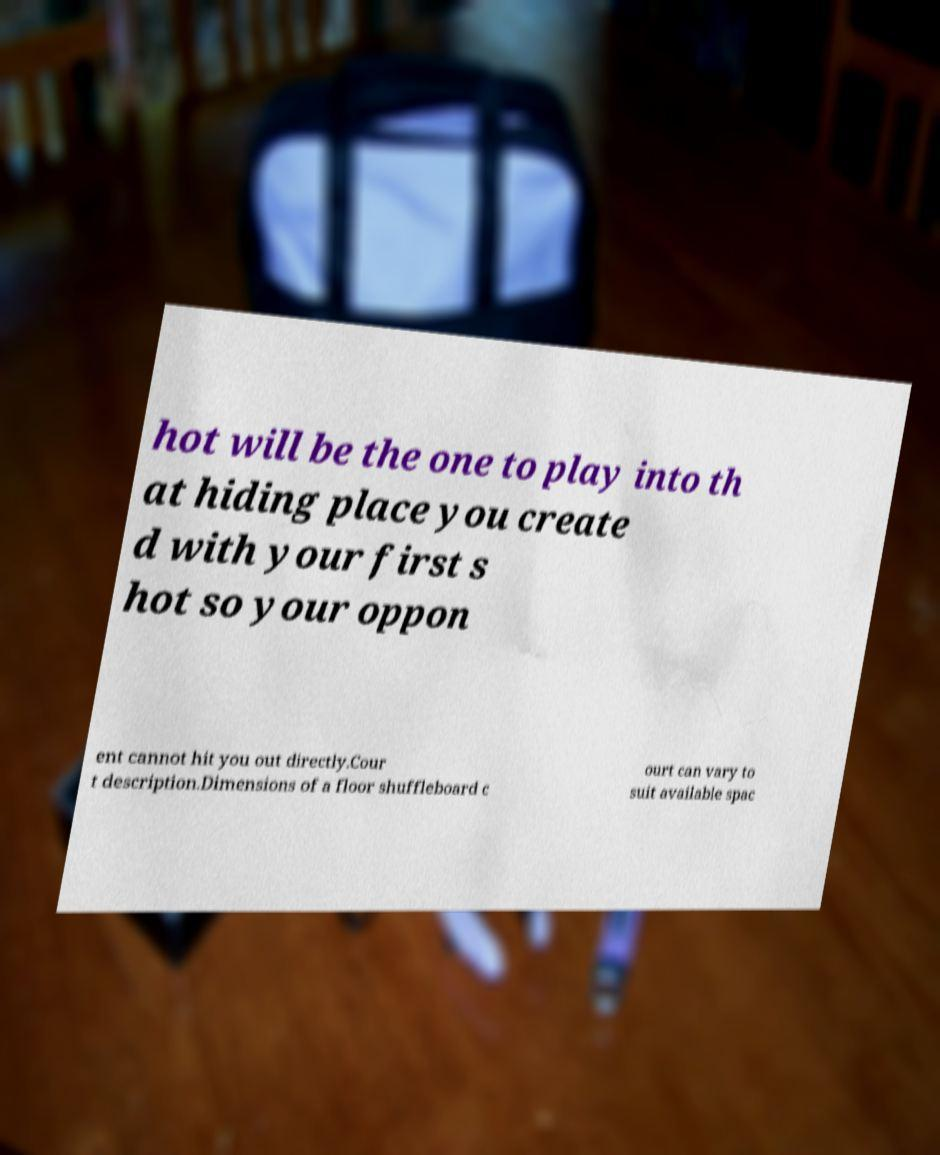There's text embedded in this image that I need extracted. Can you transcribe it verbatim? hot will be the one to play into th at hiding place you create d with your first s hot so your oppon ent cannot hit you out directly.Cour t description.Dimensions of a floor shuffleboard c ourt can vary to suit available spac 